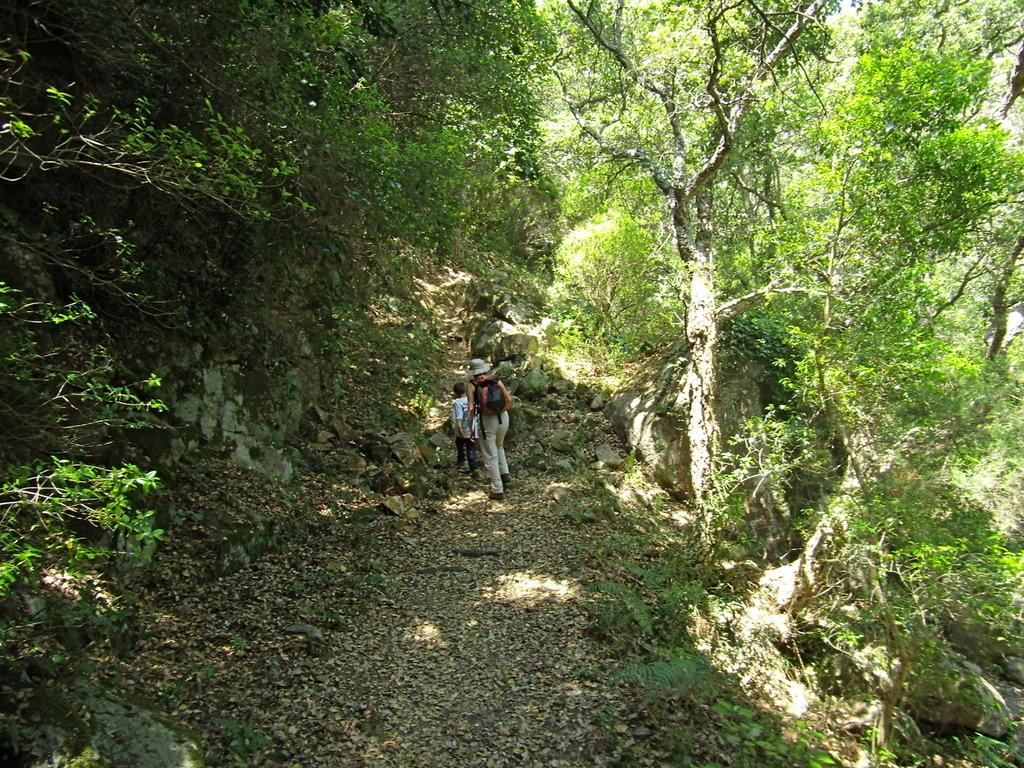Who or what is present in the image? There are people in the image. What are the people standing or sitting on? The people are on a surface. What type of natural environment can be seen in the image? There are trees visible in the image. What type of drum can be seen in the image? There is no drum present in the image. What kind of pan is being used by the people in the image? There is no pan visible in the image. 